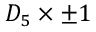Convert formula to latex. <formula><loc_0><loc_0><loc_500><loc_500>D _ { 5 } \times \pm 1</formula> 